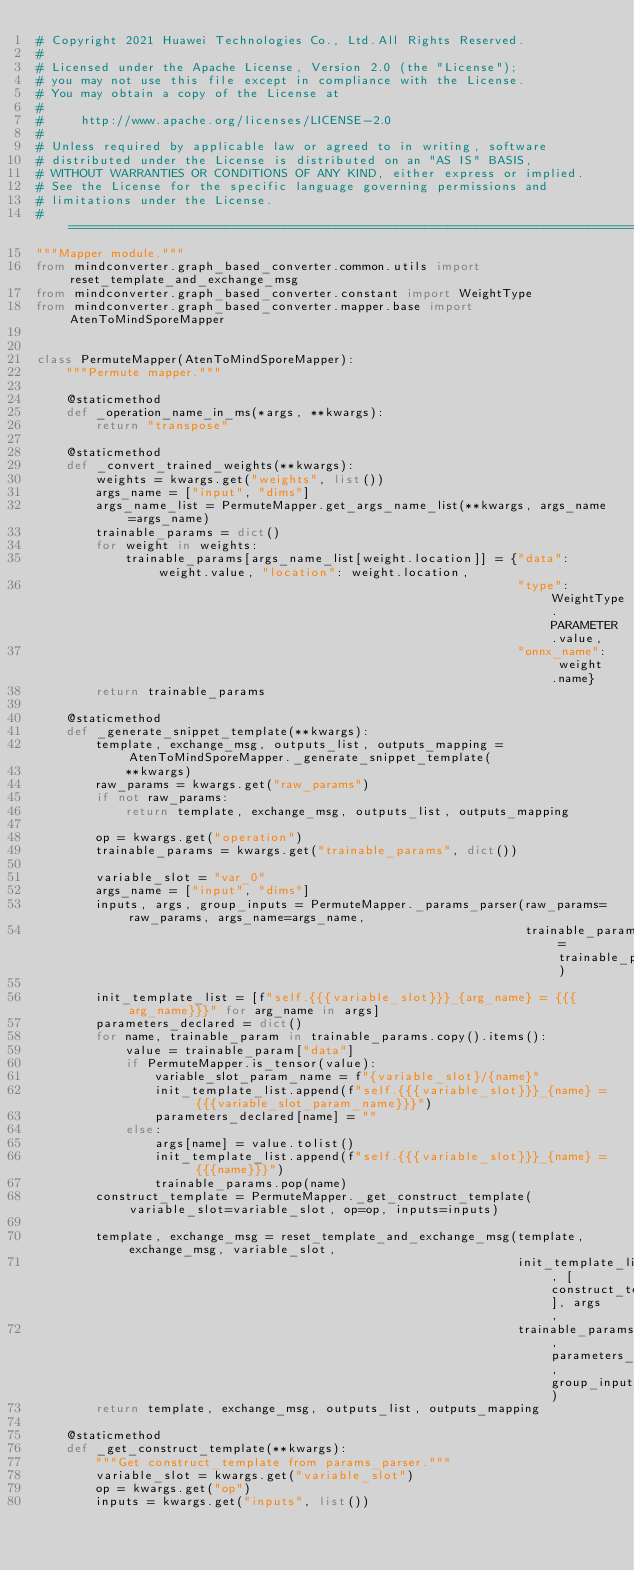Convert code to text. <code><loc_0><loc_0><loc_500><loc_500><_Python_># Copyright 2021 Huawei Technologies Co., Ltd.All Rights Reserved.
#
# Licensed under the Apache License, Version 2.0 (the "License");
# you may not use this file except in compliance with the License.
# You may obtain a copy of the License at
#
#     http://www.apache.org/licenses/LICENSE-2.0
#
# Unless required by applicable law or agreed to in writing, software
# distributed under the License is distributed on an "AS IS" BASIS,
# WITHOUT WARRANTIES OR CONDITIONS OF ANY KIND, either express or implied.
# See the License for the specific language governing permissions and
# limitations under the License.
# ==============================================================================
"""Mapper module."""
from mindconverter.graph_based_converter.common.utils import reset_template_and_exchange_msg
from mindconverter.graph_based_converter.constant import WeightType
from mindconverter.graph_based_converter.mapper.base import AtenToMindSporeMapper


class PermuteMapper(AtenToMindSporeMapper):
    """Permute mapper."""

    @staticmethod
    def _operation_name_in_ms(*args, **kwargs):
        return "transpose"

    @staticmethod
    def _convert_trained_weights(**kwargs):
        weights = kwargs.get("weights", list())
        args_name = ["input", "dims"]
        args_name_list = PermuteMapper.get_args_name_list(**kwargs, args_name=args_name)
        trainable_params = dict()
        for weight in weights:
            trainable_params[args_name_list[weight.location]] = {"data": weight.value, "location": weight.location,
                                                                 "type": WeightType.PARAMETER.value,
                                                                 "onnx_name": weight.name}
        return trainable_params

    @staticmethod
    def _generate_snippet_template(**kwargs):
        template, exchange_msg, outputs_list, outputs_mapping = AtenToMindSporeMapper._generate_snippet_template(
            **kwargs)
        raw_params = kwargs.get("raw_params")
        if not raw_params:
            return template, exchange_msg, outputs_list, outputs_mapping

        op = kwargs.get("operation")
        trainable_params = kwargs.get("trainable_params", dict())

        variable_slot = "var_0"
        args_name = ["input", "dims"]
        inputs, args, group_inputs = PermuteMapper._params_parser(raw_params=raw_params, args_name=args_name,
                                                                  trainable_params=trainable_params)

        init_template_list = [f"self.{{{variable_slot}}}_{arg_name} = {{{arg_name}}}" for arg_name in args]
        parameters_declared = dict()
        for name, trainable_param in trainable_params.copy().items():
            value = trainable_param["data"]
            if PermuteMapper.is_tensor(value):
                variable_slot_param_name = f"{variable_slot}/{name}"
                init_template_list.append(f"self.{{{variable_slot}}}_{name} = {{{variable_slot_param_name}}}")
                parameters_declared[name] = ""
            else:
                args[name] = value.tolist()
                init_template_list.append(f"self.{{{variable_slot}}}_{name} = {{{name}}}")
                trainable_params.pop(name)
        construct_template = PermuteMapper._get_construct_template(variable_slot=variable_slot, op=op, inputs=inputs)

        template, exchange_msg = reset_template_and_exchange_msg(template, exchange_msg, variable_slot,
                                                                 init_template_list, [construct_template], args,
                                                                 trainable_params, parameters_declared, group_inputs)
        return template, exchange_msg, outputs_list, outputs_mapping

    @staticmethod
    def _get_construct_template(**kwargs):
        """Get construct_template from params_parser."""
        variable_slot = kwargs.get("variable_slot")
        op = kwargs.get("op")
        inputs = kwargs.get("inputs", list())</code> 